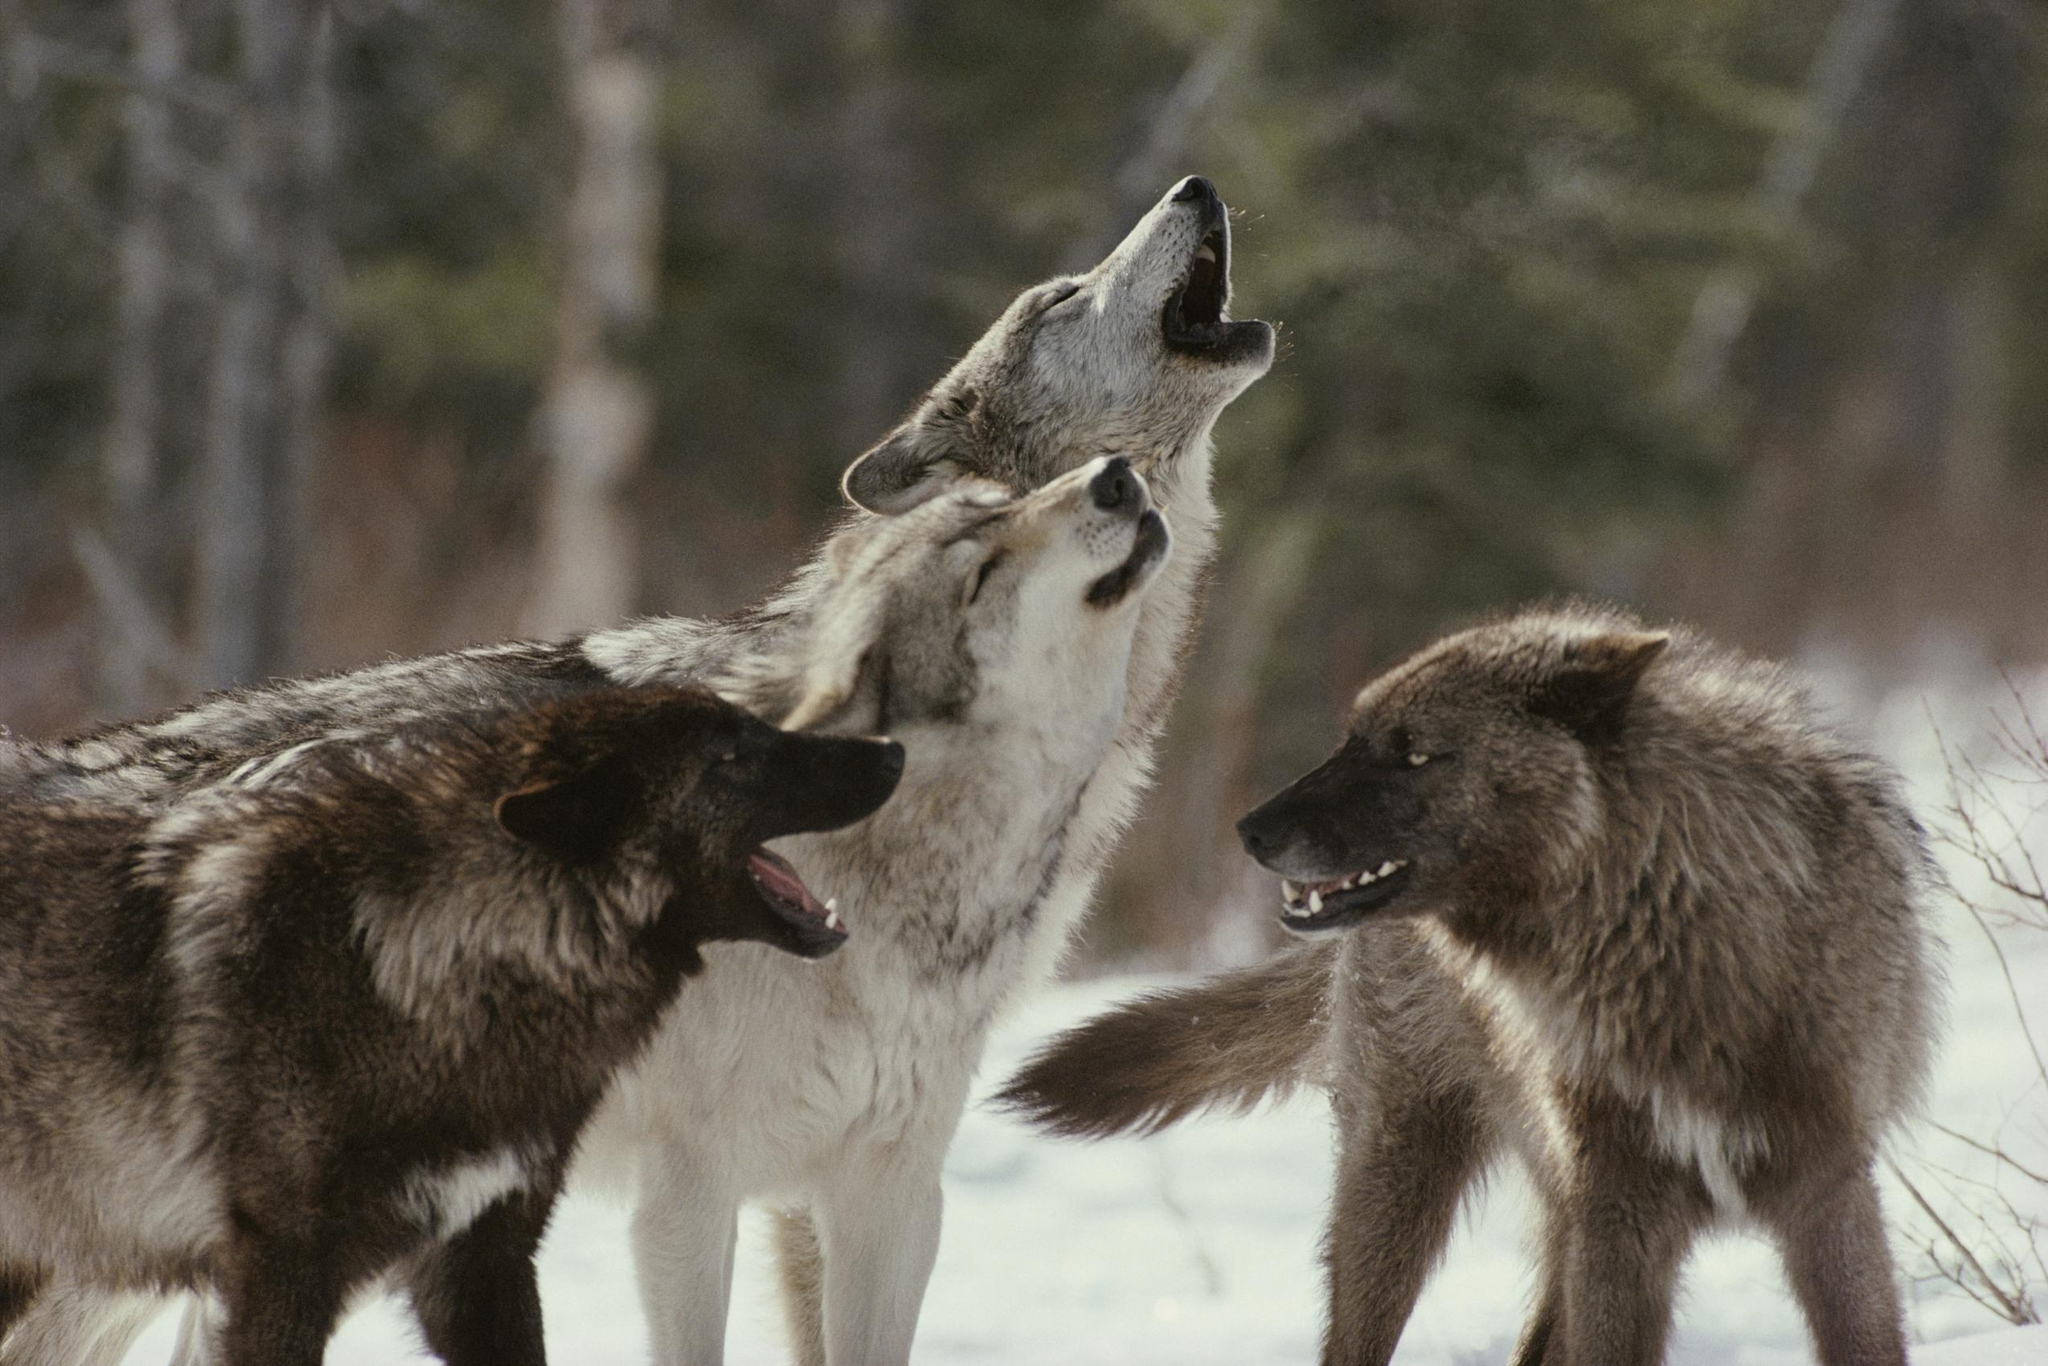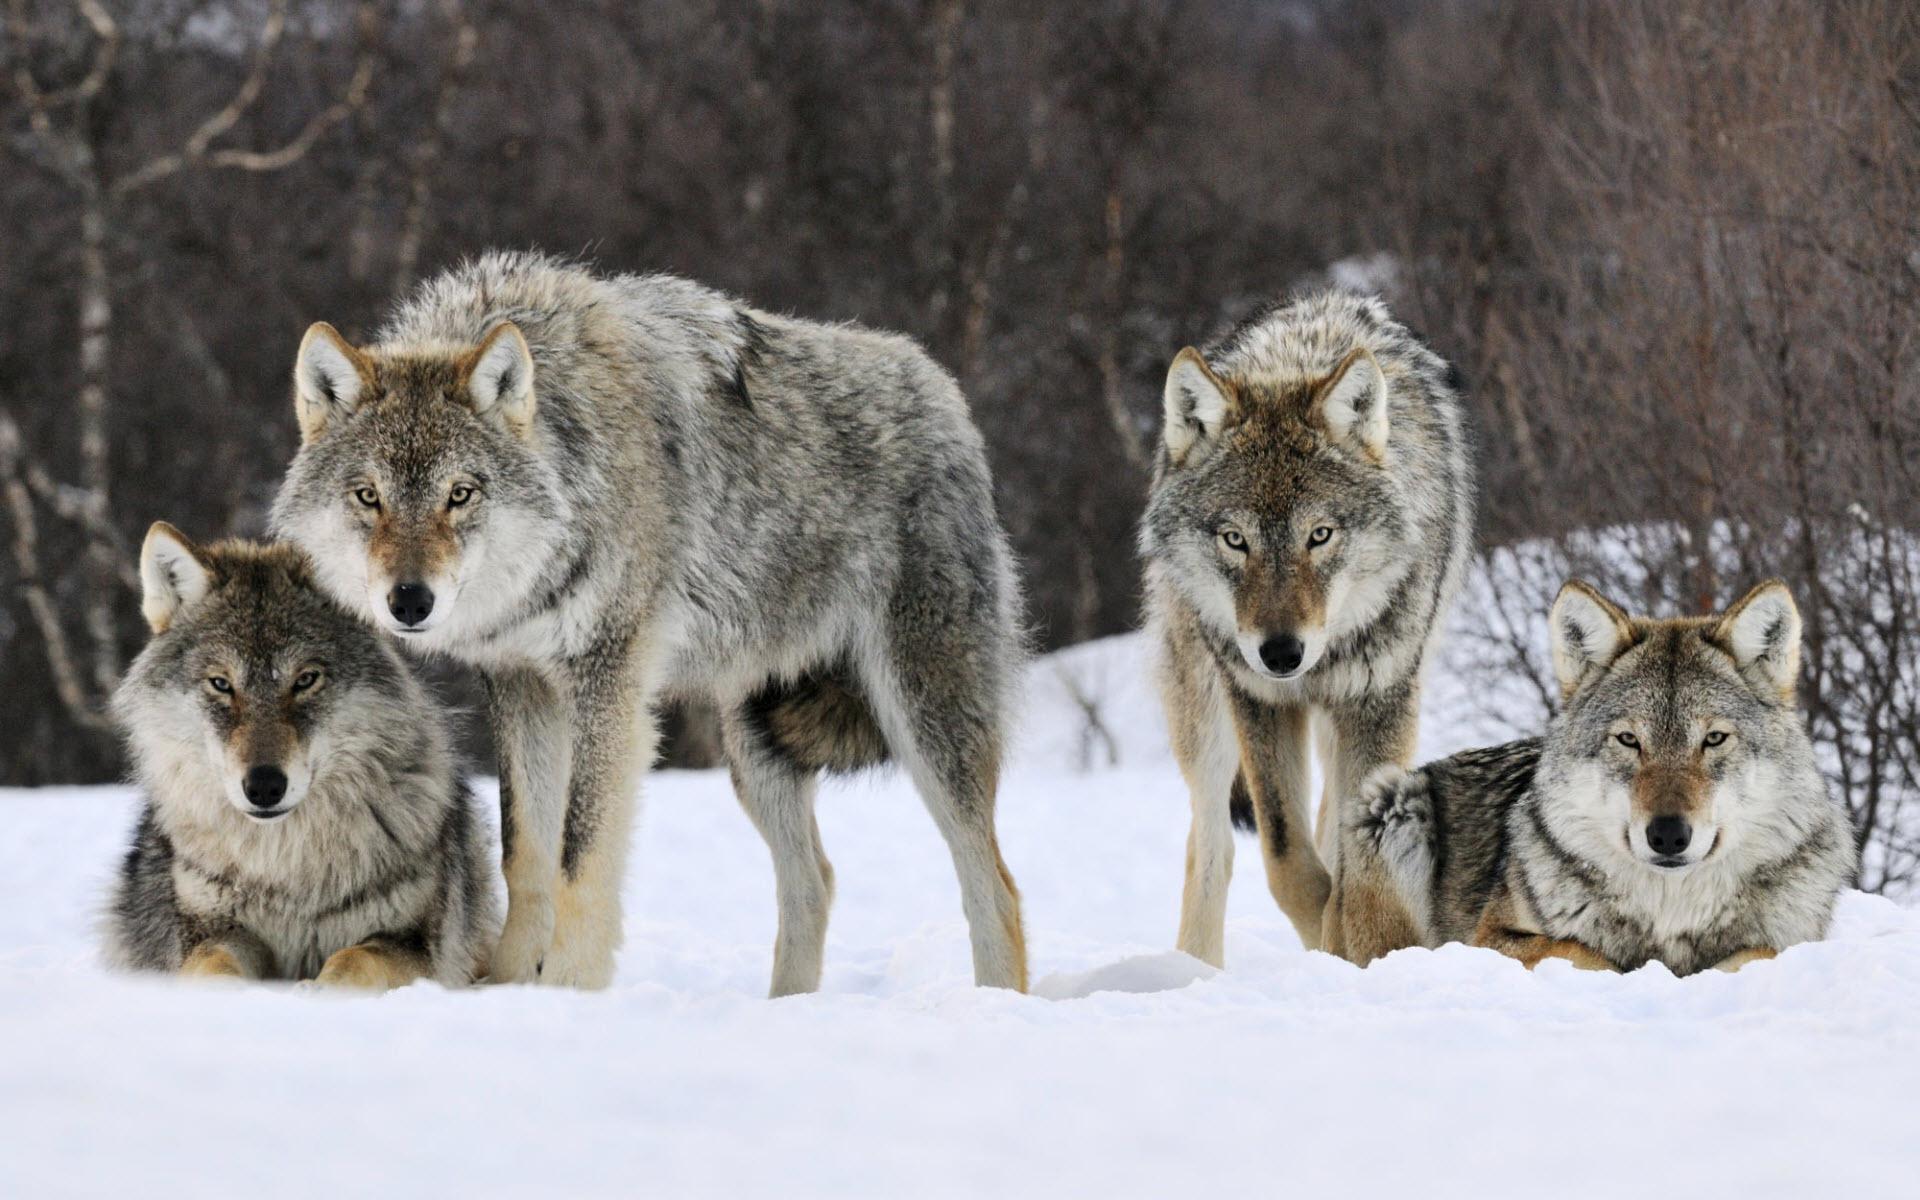The first image is the image on the left, the second image is the image on the right. Assess this claim about the two images: "One image shows two wolves with one wolf on the ground and one standing, and the other image shows one wolf with all teeth bared and visible.". Correct or not? Answer yes or no. No. The first image is the image on the left, the second image is the image on the right. Assess this claim about the two images: "There is no more than one wolf in the right image.". Correct or not? Answer yes or no. No. 